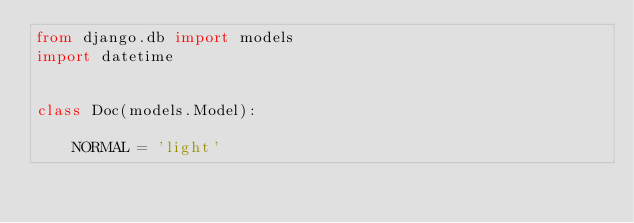Convert code to text. <code><loc_0><loc_0><loc_500><loc_500><_Python_>from django.db import models
import datetime


class Doc(models.Model):

    NORMAL = 'light'</code> 